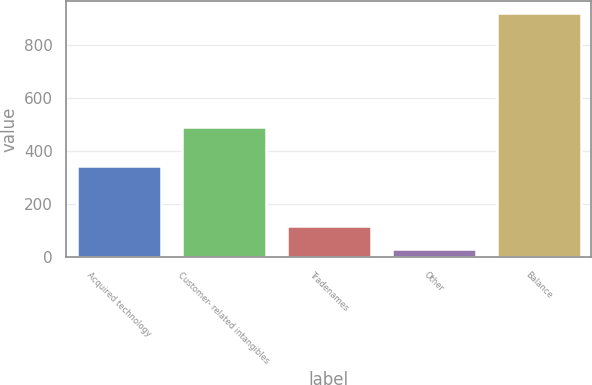Convert chart. <chart><loc_0><loc_0><loc_500><loc_500><bar_chart><fcel>Acquired technology<fcel>Customer- related intangibles<fcel>Tradenames<fcel>Other<fcel>Balance<nl><fcel>342<fcel>491<fcel>118<fcel>29<fcel>919<nl></chart> 